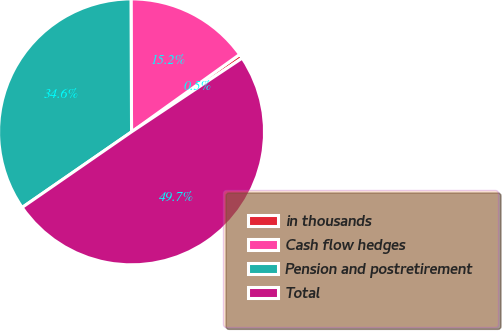Convert chart to OTSL. <chart><loc_0><loc_0><loc_500><loc_500><pie_chart><fcel>in thousands<fcel>Cash flow hedges<fcel>Pension and postretirement<fcel>Total<nl><fcel>0.54%<fcel>15.17%<fcel>34.56%<fcel>49.73%<nl></chart> 